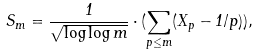<formula> <loc_0><loc_0><loc_500><loc_500>S _ { m } = \frac { 1 } { \sqrt { \log \log m } } \cdot ( \sum _ { p \leq m } ( X _ { p } - 1 / p ) ) ,</formula> 